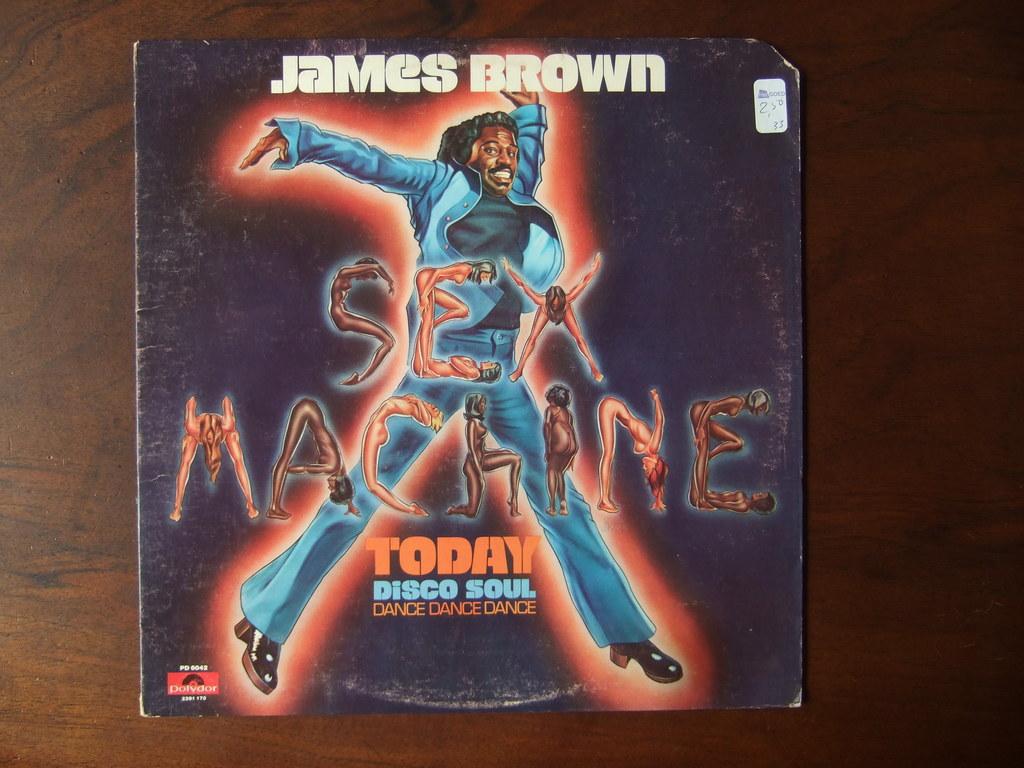Who is the singer on this album?
Provide a succinct answer. James brown. What is the name of this record?
Make the answer very short. Sex machine. 